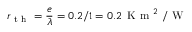Convert formula to latex. <formula><loc_0><loc_0><loc_500><loc_500>r _ { t h } = \frac { e } { \lambda } = 0 . 2 / 1 = 0 . 2 \, K m ^ { 2 } / W</formula> 